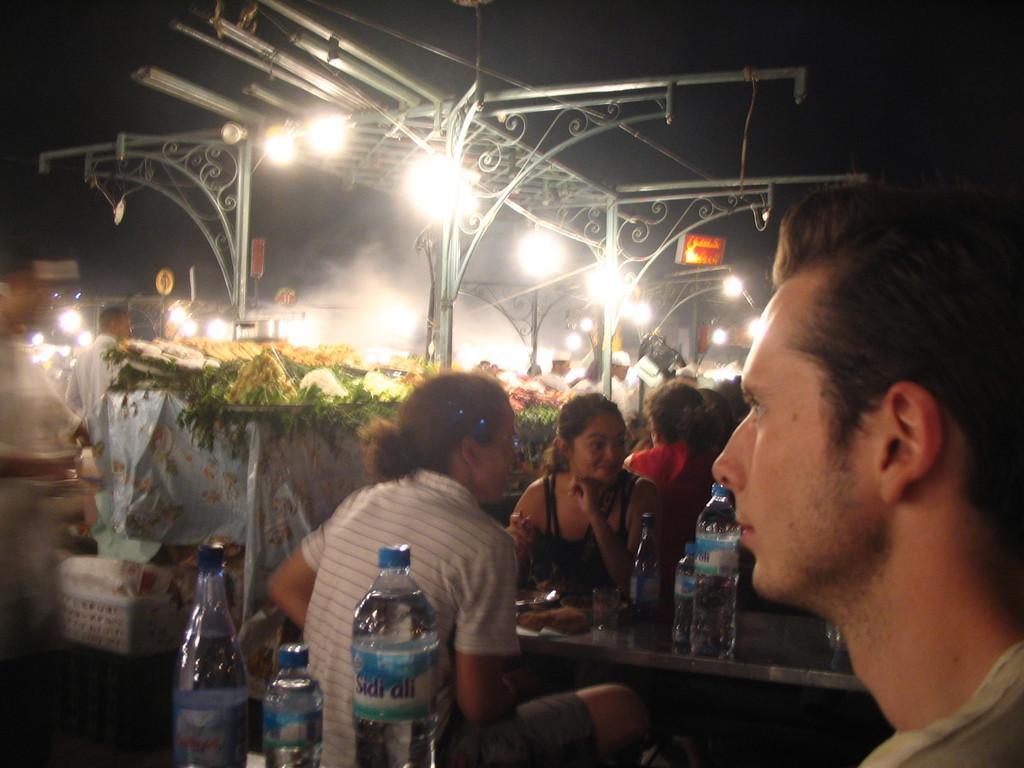In one or two sentences, can you explain what this image depicts? In this picture to the right side there is a man sitting. In front of him there are three water bottles. Beside him there are two ladies sitting and talking. In between them there is a table with glass and three water bottles on it. And at the back of them there is a lady with red dress is sitting. On the top there are lights. And on the tables there are vegetables to the left side. And there are some people standing at the back side. 